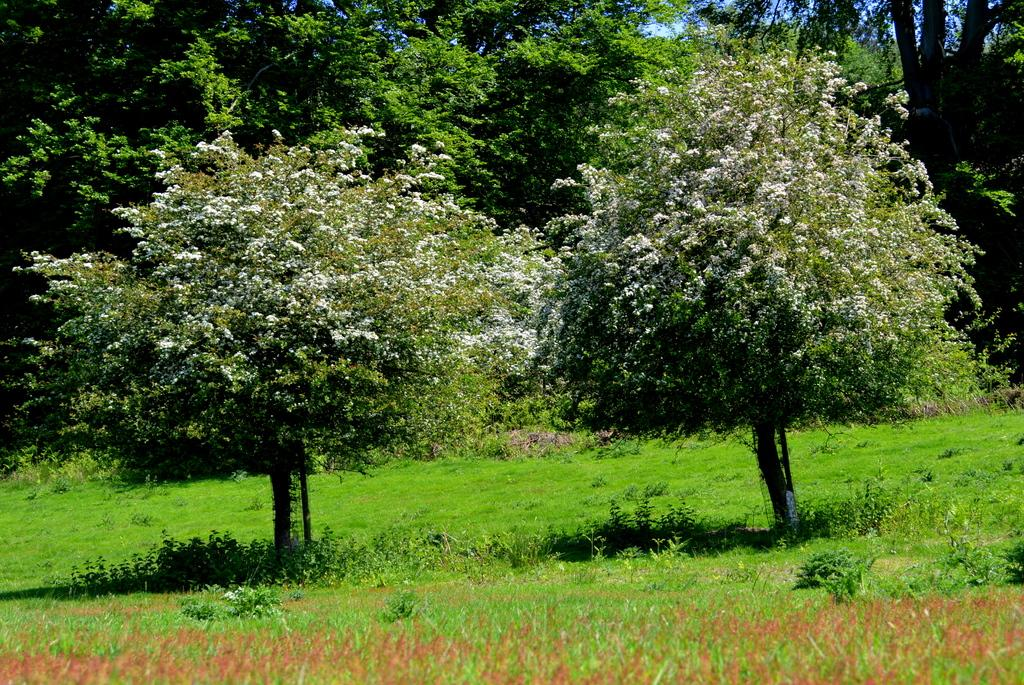What type of vegetation can be seen in the image? There are trees and grass in the image. Can you describe the ground in the image? The ground is covered with grass in the image. What is the natural setting depicted in the image? The natural setting includes trees and grass. How many nails can be seen sticking out of the trees in the image? There are no nails present in the image; it features trees and grass in a natural setting. 